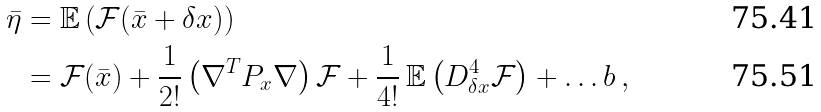<formula> <loc_0><loc_0><loc_500><loc_500>\bar { \eta } & = \mathbb { E } \left ( \mathcal { F } ( \bar { x } + \delta x ) \right ) \\ \quad & = \mathcal { F } ( \bar { x } ) + \frac { 1 } { 2 ! } \left ( \nabla ^ { T } P _ { x } \nabla \right ) \mathcal { F } + \frac { 1 } { 4 ! } \, \mathbb { E } \left ( D _ { \delta x } ^ { 4 } \mathcal { F } \right ) + \dots b \, ,</formula> 